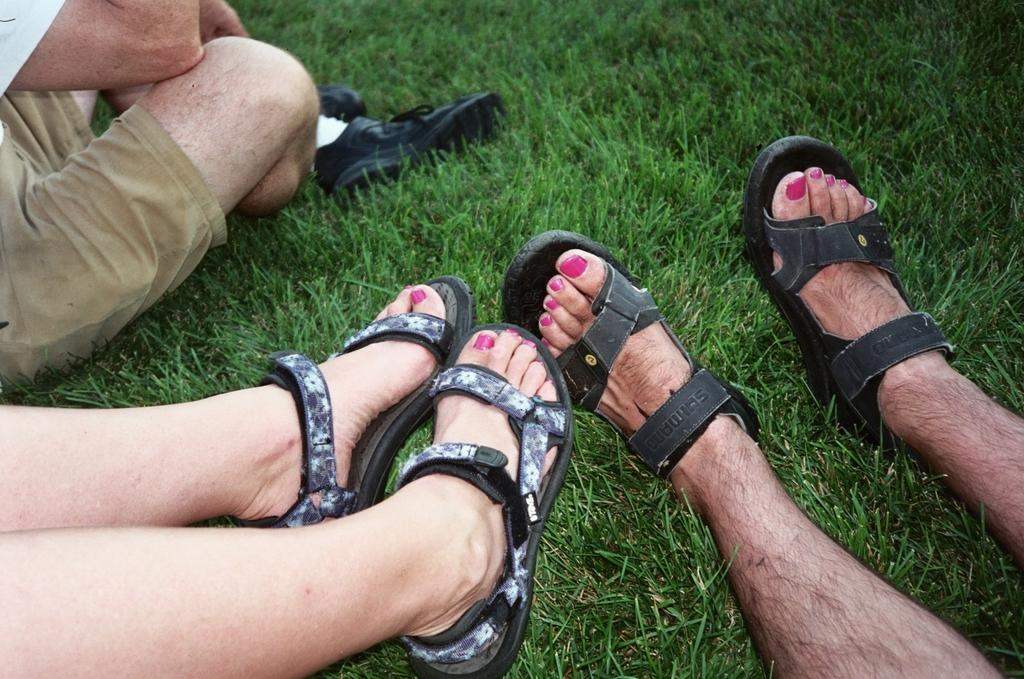How many people are present in the image? There are two people in the image. What part of the people's bodies can be seen in the image? The legs of the two people are visible. Are the people wearing any footwear? Yes, both people are wearing footwear. What is the person sitting on in the image? The person is sitting on the grass in the image. Can you see any nests in the image? There is no mention of nests in the provided facts, so it cannot be determined if any are present in the image. Are there any dinosaurs visible in the image? There is no mention of dinosaurs in the provided facts, so it cannot be determined if any are present in the image. 